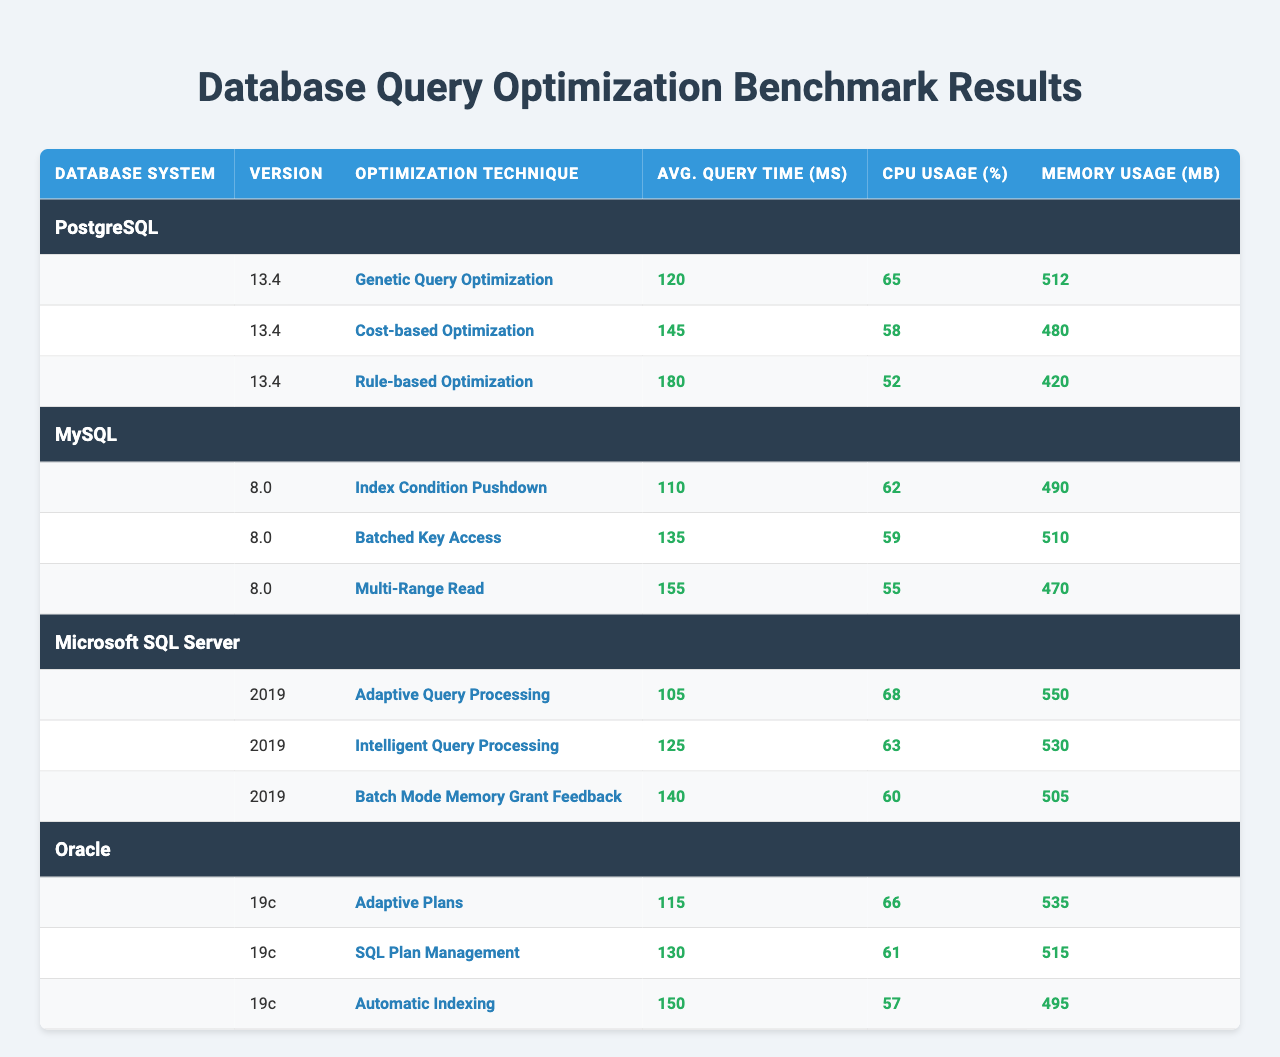What is the average query time for the "Adaptive Query Processing" technique in Microsoft SQL Server? The table shows that the average query time for the "Adaptive Query Processing" technique in Microsoft SQL Server is 105 ms, as listed under Avg. Query Time (ms) for that specific technique.
Answer: 105 ms Which database system uses "Genetic Query Optimization" as a technique and what is its average query time? The table indicates that "Genetic Query Optimization" is used by PostgreSQL, and the average query time associated with this technique is 120 ms.
Answer: PostgreSQL, 120 ms Is the CPU usage for "Cost-based Optimization" in PostgreSQL higher or lower than the CPU usage for "Batched Key Access" in MySQL? The CPU usage for "Cost-based Optimization" in PostgreSQL is 58%, while for "Batched Key Access" in MySQL it is 59%. Since 58% is less than 59%, the CPU usage for "Cost-based Optimization" is lower.
Answer: Lower What is the total memory usage across all optimization techniques for Oracle? By adding the memory usage values: 535 + 515 + 495 = 1545 MB, we find the total memory usage for Oracle across its optimization techniques.
Answer: 1545 MB Which technique has the highest average query time in the chart? The table displays the average query times, and "Rule-based Optimization" in PostgreSQL has the highest query time at 180 ms compared to other techniques listed across all database systems.
Answer: Rule-based Optimization What is the difference in average query time between "Multi-Range Read" in MySQL and "Automatic Indexing" in Oracle? The average query time for "Multi-Range Read" in MySQL is 155 ms, and for "Automatic Indexing" in Oracle, it is 150 ms. The difference is 155 - 150 = 5 ms.
Answer: 5 ms Which optimization technique among all listed consumes the least CPU usage? The table shows that "Rule-based Optimization" in PostgreSQL uses 52% CPU, which is the lowest among all techniques displayed in the table.
Answer: Rule-based Optimization Does Microsoft SQL Server have an optimization technique with an average query time below 120 ms? Looking at the table, "Adaptive Query Processing" has an average query time of 105 ms, which is below 120 ms. Thus, the statement is true.
Answer: Yes What is the relationship between average query time and CPU usage for the "Index Condition Pushdown" technique in MySQL? The table shows that "Index Condition Pushdown" has an average query time of 110 ms and CPU usage of 62%. Analyzing this, we see that as the average query time is relatively low, the CPU usage is moderate, indicating efficient processing for this technique.
Answer: Moderate efficiency What query optimization technique has the second-lowest average query time in PostgreSQL? In PostgreSQL, the techniques and their times are listed as follows: 120 ms (Genetic Query Optimization), 145 ms (Cost-based Optimization), and 180 ms (Rule-based Optimization). Therefore, "Cost-based Optimization" is the second-lowest with 145 ms.
Answer: Cost-based Optimization 